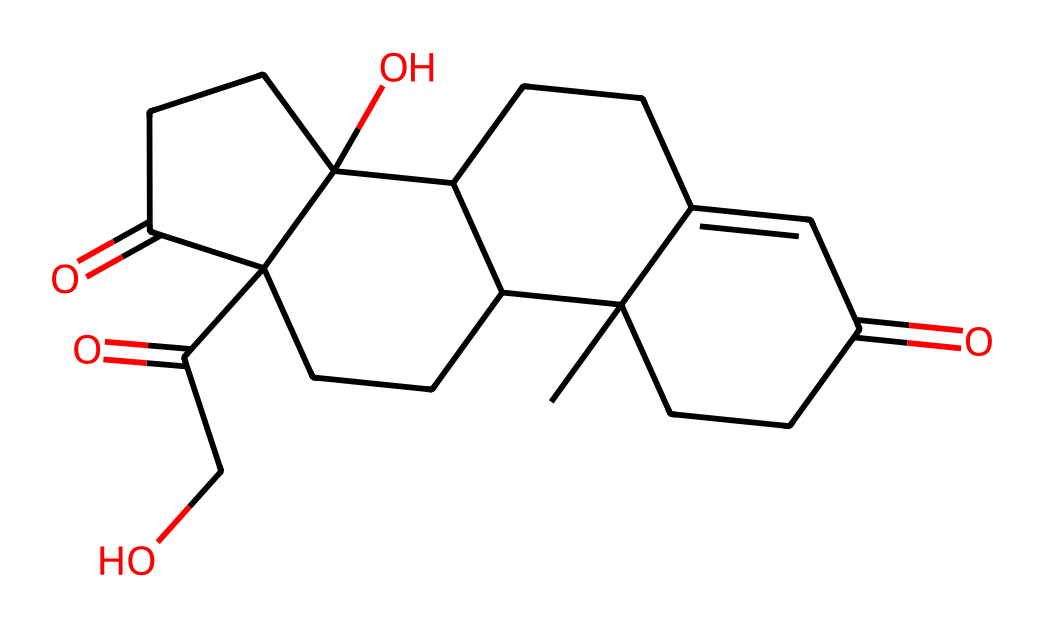how many carbon atoms are in the cortisol structure? To find the number of carbon atoms, we can analyze the SMILES representation. Each "C" represents a carbon atom. Counting the "C" characters in the SMILES string gives us a total of 21 carbon atoms.
Answer: 21 what functional groups are present in cortisol? By examining the SMILES string, we can identify carbonyl (C=O) and hydroxyl (O) functional groups. There are multiple instances of C=O throughout the structure and at least one -OH group.
Answer: carbonyl and hydroxyl what is the total number of rings in the cortisol structure? The structure of cortisol can be interpreted from the SMILES notation by identifying the cyclical regions determined by the "C" connections. In total, there are four distinct rings in the structure.
Answer: 4 which part of this chemical is responsible for its classification as a steroid? Cortisol has a characteristic four-ring core structure that is typical of steroids. The arrangement and fusion of these rings indicate its steroid classification.
Answer: four-ring core how many oxygen atoms are present in the cortisol structure? In the SMILES representation, each "O" indicates an oxygen atom. By counting the occurrences of "O" in the SMILES, we determine that there are five oxygen atoms in the structure.
Answer: 5 